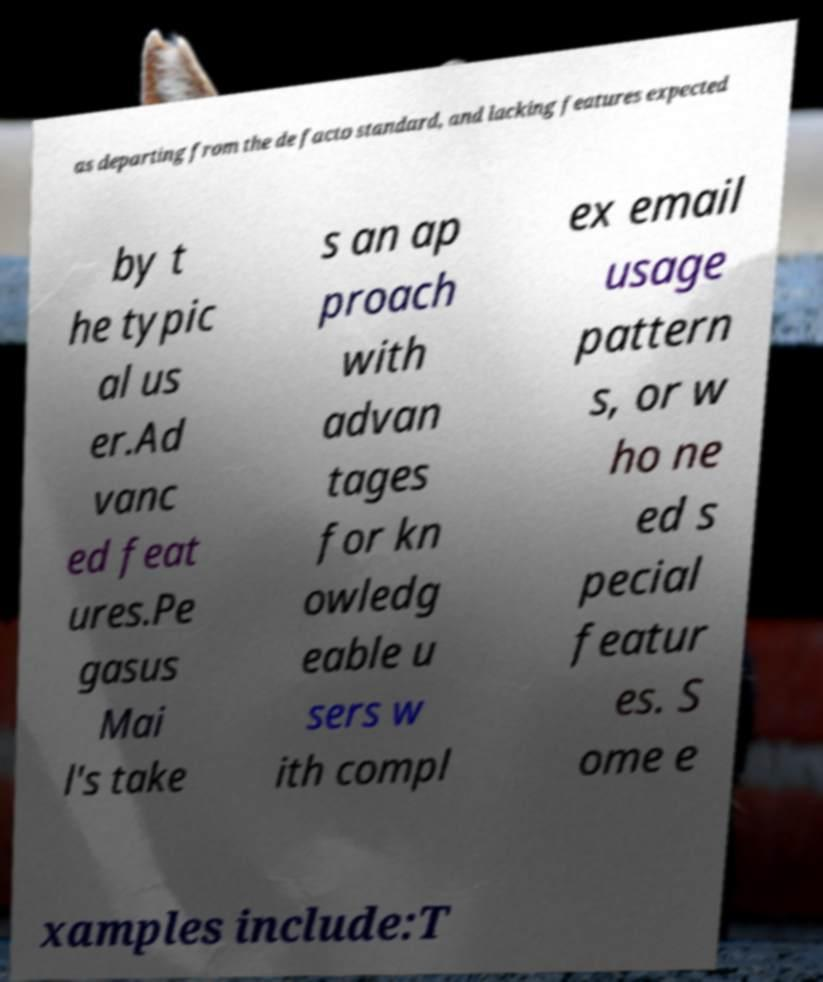What messages or text are displayed in this image? I need them in a readable, typed format. as departing from the de facto standard, and lacking features expected by t he typic al us er.Ad vanc ed feat ures.Pe gasus Mai l's take s an ap proach with advan tages for kn owledg eable u sers w ith compl ex email usage pattern s, or w ho ne ed s pecial featur es. S ome e xamples include:T 